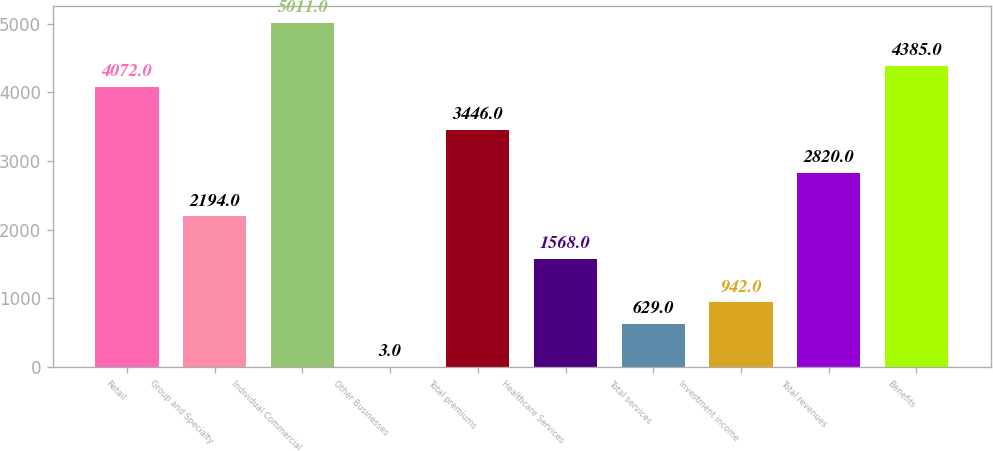Convert chart. <chart><loc_0><loc_0><loc_500><loc_500><bar_chart><fcel>Retail<fcel>Group and Specialty<fcel>Individual Commercial<fcel>Other Businesses<fcel>Total premiums<fcel>Healthcare Services<fcel>Total services<fcel>Investment income<fcel>Total revenues<fcel>Benefits<nl><fcel>4072<fcel>2194<fcel>5011<fcel>3<fcel>3446<fcel>1568<fcel>629<fcel>942<fcel>2820<fcel>4385<nl></chart> 